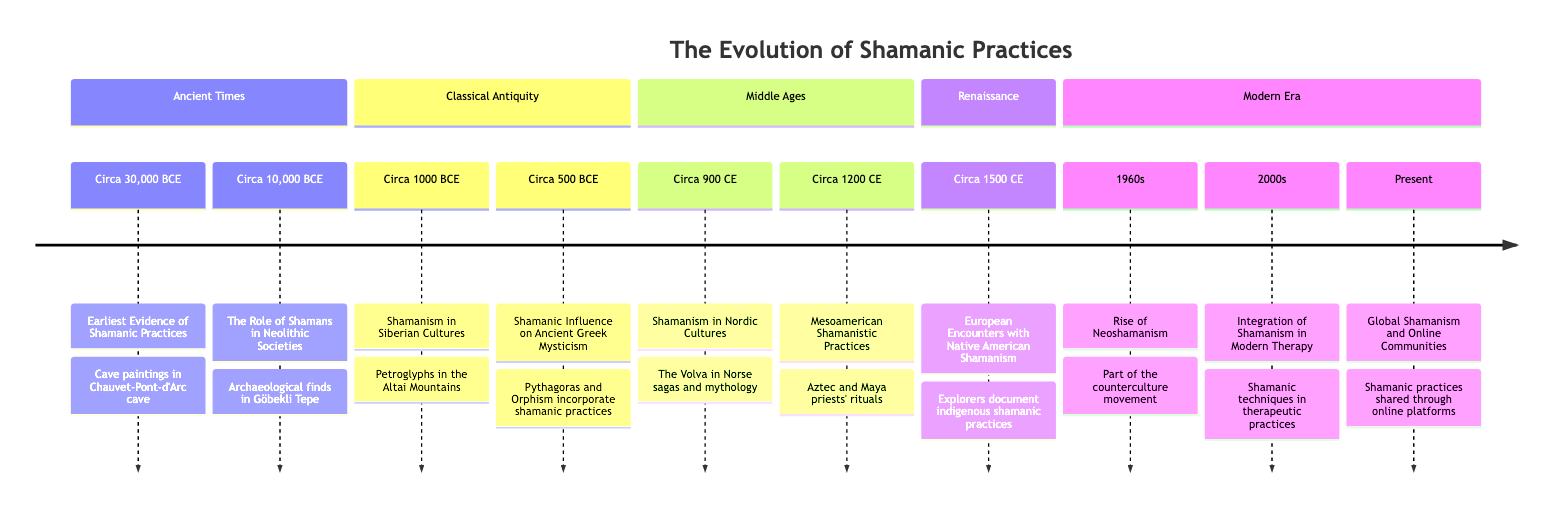What is the earliest date mentioned in this timeline? The timeline starts with the event "Earliest Evidence of Shamanic Practices" dated circa 30,000 BCE. By referring to the elements in the "Ancient Times" section, this date is confirmed as the earliest in the entire timeline.
Answer: Circa 30,000 BCE Which era features the influence of shamanism on Ancient Greek mysticism? The event titled "Shamanic Influence on Ancient Greek Mysticism" is found in the "Classical Antiquity" section, indicating that this era includes shamanism's influence on Greek mysticism.
Answer: Classical Antiquity How many major eras are represented in the timeline? The timeline is divided into five distinct eras: Ancient Times, Classical Antiquity, Middle Ages, Renaissance, and Modern Era. Counting these sections gives the total number of major eras represented.
Answer: 5 What specific event occurred circa 1960s related to shamanism? The event listed for the circa 1960s is "Rise of Neoshamanism," which is acknowledged in the "Modern Era" section of the timeline. This identifies the resurgence of interest in shamanic practices during that period.
Answer: Rise of Neoshamanism What shamanic practices were noted in Mesoamerica during the Middle Ages? "Mesoamerican Shamanistic Practices" is the event listed in the Middle Ages section, which describes Aztec and Maya priests using hallucinogenic plants in their rituals. This points to specific practices involved during that period.
Answer: Aztec and Maya priests Which event discusses the integration of shamanism into modern therapy? The timeline specifies "Integration of Shamanism in Modern Therapy," located in the Modern Era section. The mention of psychologists and therapists integrating shamanic techniques into therapeutic practices confirms the merging of these two fields.
Answer: Integration of Shamanism in Modern Therapy Which era has the fewest documented events? By analyzing the sections of the timeline, the era titled "Renaissance" features only one documented event, which is "European Encounters with Native American Shamanism." This makes it the era with the fewest events.
Answer: Renaissance What common theme is present in both events of the Modern Era? The events listed in the Modern Era, "Rise of Neoshamanism" and "Integration of Shamanism in Modern Therapy," both involve the adaptation and modern interpretation of traditional shamanic practices. This theme of contemporary relevance is noticeable through both events.
Answer: Adaptation of shamanic practices Which region's shamanism is mentioned in the event dated circa 1000 BCE? The event titled "Shamanism in Siberian Cultures," dated circa 1000 BCE, specifically refers to shamanic practices within Siberian cultures, indicating where these practices were documented.
Answer: Siberian Cultures 